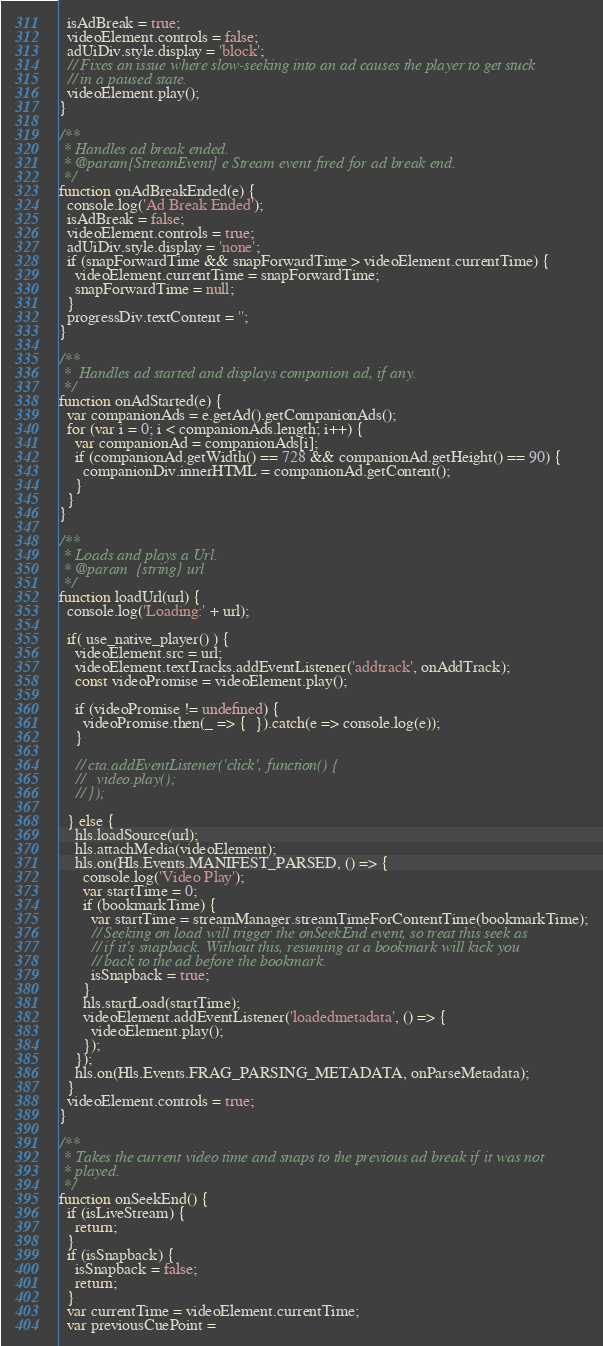Convert code to text. <code><loc_0><loc_0><loc_500><loc_500><_JavaScript_>  isAdBreak = true;
  videoElement.controls = false;
  adUiDiv.style.display = 'block';
  // Fixes an issue where slow-seeking into an ad causes the player to get stuck
  // in a paused state.
  videoElement.play();
}

/**
 * Handles ad break ended.
 * @param{StreamEvent} e Stream event fired for ad break end.
 */
function onAdBreakEnded(e) {
  console.log('Ad Break Ended');
  isAdBreak = false;
  videoElement.controls = true;
  adUiDiv.style.display = 'none';
  if (snapForwardTime && snapForwardTime > videoElement.currentTime) {
    videoElement.currentTime = snapForwardTime;
    snapForwardTime = null;
  }
  progressDiv.textContent = '';
}

/**
 *  Handles ad started and displays companion ad, if any.
 */
function onAdStarted(e) {
  var companionAds = e.getAd().getCompanionAds();
  for (var i = 0; i < companionAds.length; i++) {
    var companionAd = companionAds[i];
    if (companionAd.getWidth() == 728 && companionAd.getHeight() == 90) {
      companionDiv.innerHTML = companionAd.getContent();
    }
  }
}

/**
 * Loads and plays a Url.
 * @param  {string} url
 */
function loadUrl(url) {
  console.log('Loading:' + url);
  
  if( use_native_player() ) {
    videoElement.src = url;
    videoElement.textTracks.addEventListener('addtrack', onAddTrack);
    const videoPromise = videoElement.play();

    if (videoPromise != undefined) {
      videoPromise.then(_ => {  }).catch(e => console.log(e));
    }

    // cta.addEventListener('click', function() {
    //   video.play();
    // });
    
  } else {
    hls.loadSource(url);
    hls.attachMedia(videoElement);
    hls.on(Hls.Events.MANIFEST_PARSED, () => {
      console.log('Video Play');
      var startTime = 0;
      if (bookmarkTime) {
        var startTime = streamManager.streamTimeForContentTime(bookmarkTime);
        // Seeking on load will trigger the onSeekEnd event, so treat this seek as
        // if it's snapback. Without this, resuming at a bookmark will kick you
        // back to the ad before the bookmark.
        isSnapback = true;
      }
      hls.startLoad(startTime);
      videoElement.addEventListener('loadedmetadata', () => {
        videoElement.play();
      });
    });
    hls.on(Hls.Events.FRAG_PARSING_METADATA, onParseMetadata);
  }
  videoElement.controls = true;
}

/**
 * Takes the current video time and snaps to the previous ad break if it was not
 * played.
 */
function onSeekEnd() {
  if (isLiveStream) {
    return;
  }
  if (isSnapback) {
    isSnapback = false;
    return;
  }
  var currentTime = videoElement.currentTime;
  var previousCuePoint =</code> 